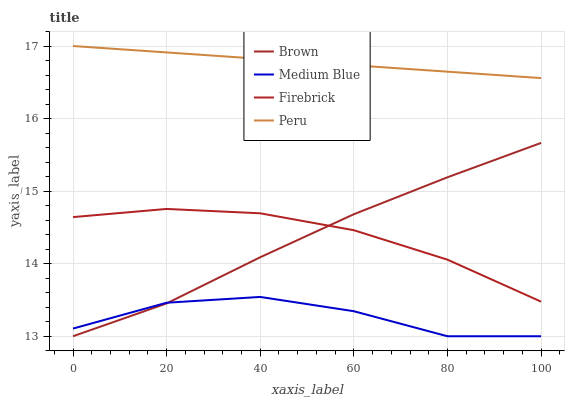Does Medium Blue have the minimum area under the curve?
Answer yes or no. Yes. Does Peru have the maximum area under the curve?
Answer yes or no. Yes. Does Firebrick have the minimum area under the curve?
Answer yes or no. No. Does Firebrick have the maximum area under the curve?
Answer yes or no. No. Is Peru the smoothest?
Answer yes or no. Yes. Is Medium Blue the roughest?
Answer yes or no. Yes. Is Firebrick the smoothest?
Answer yes or no. No. Is Firebrick the roughest?
Answer yes or no. No. Does Brown have the lowest value?
Answer yes or no. Yes. Does Firebrick have the lowest value?
Answer yes or no. No. Does Peru have the highest value?
Answer yes or no. Yes. Does Firebrick have the highest value?
Answer yes or no. No. Is Medium Blue less than Peru?
Answer yes or no. Yes. Is Peru greater than Firebrick?
Answer yes or no. Yes. Does Brown intersect Firebrick?
Answer yes or no. Yes. Is Brown less than Firebrick?
Answer yes or no. No. Is Brown greater than Firebrick?
Answer yes or no. No. Does Medium Blue intersect Peru?
Answer yes or no. No. 